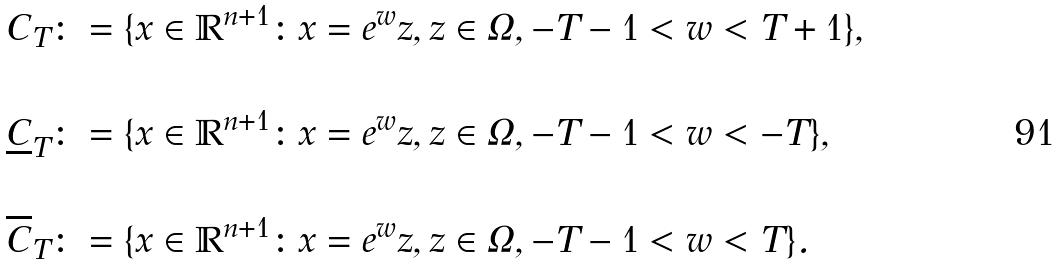<formula> <loc_0><loc_0><loc_500><loc_500>& C _ { T } \colon = \{ x \in \mathbb { R } ^ { n + 1 } \colon x = e ^ { w } z , z \in \Omega , - T - 1 < w < T + 1 \} , \\ \ \\ & \underline { C } _ { T } \colon = \{ x \in \mathbb { R } ^ { n + 1 } \colon x = e ^ { w } z , z \in \Omega , - T - 1 < w < - T \} , \\ \ \\ & \overline { C } _ { T } \colon = \{ x \in \mathbb { R } ^ { n + 1 } \colon x = e ^ { w } z , z \in \Omega , - T - 1 < w < T \} .</formula> 